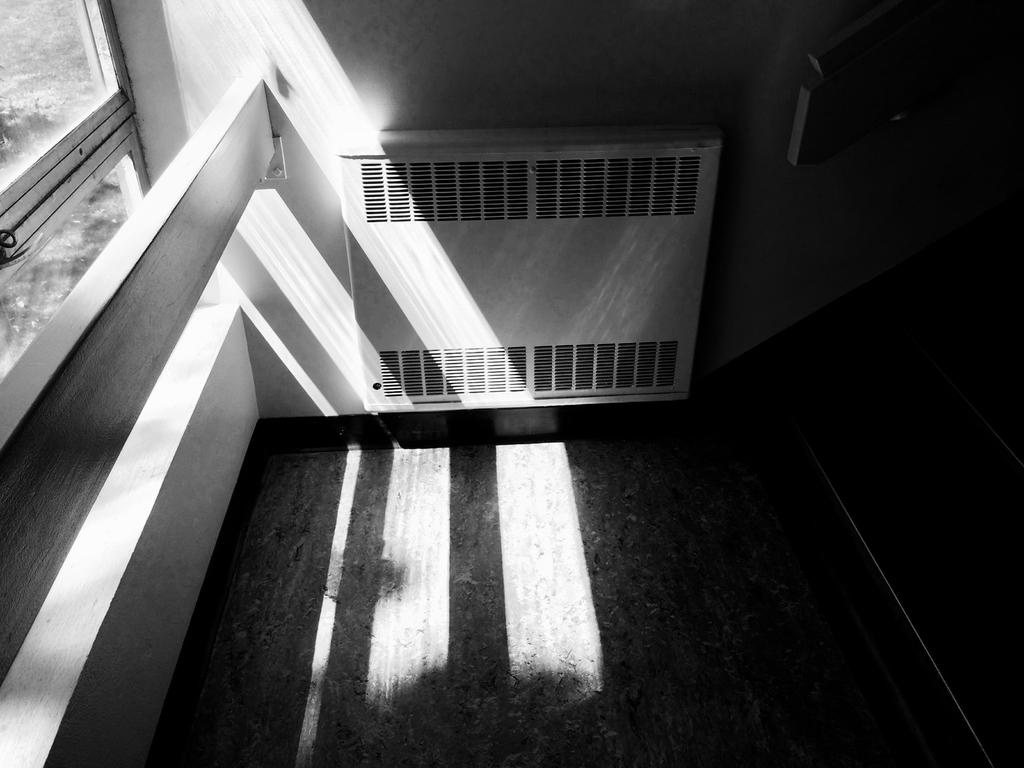What is attached to the wall in the image? There is an object attached to the wall in the image, but we cannot determine its specific nature from the given facts. What can be seen in the left corner of the image? There is a glass window in the left corner of the image. What architectural feature is present in the right corner of the image? There is a staircase in the right corner of the image. What type of group is depicted in the image after the event? There is no group or event depicted in the image; it only shows an object attached to the wall, a glass window, and a staircase. Where is the drawer located in the image? There is no drawer present in the image. 